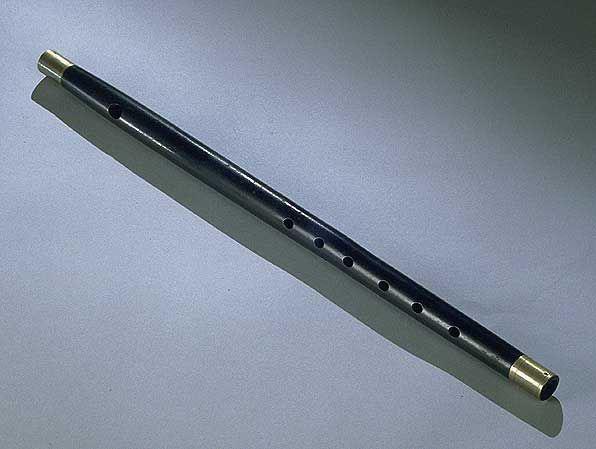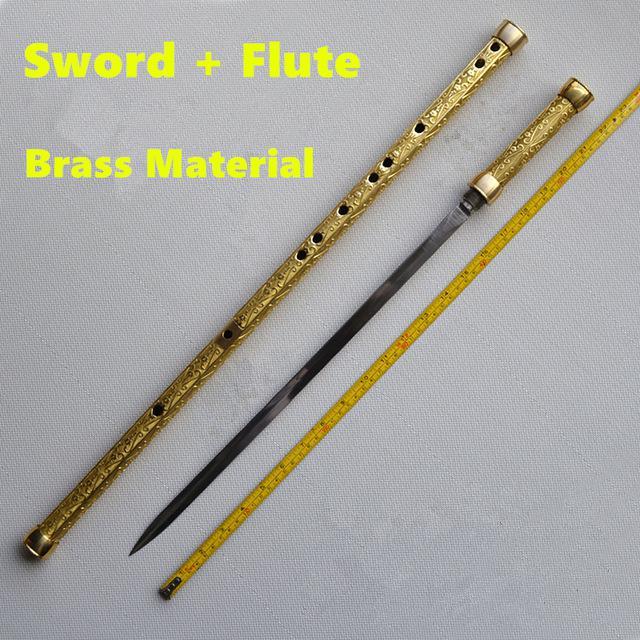The first image is the image on the left, the second image is the image on the right. Analyze the images presented: Is the assertion "The left image shows only a flute displayed at an angle, and the right image shows a measuring tape, a sword and a flute displayed diagonally." valid? Answer yes or no. Yes. 